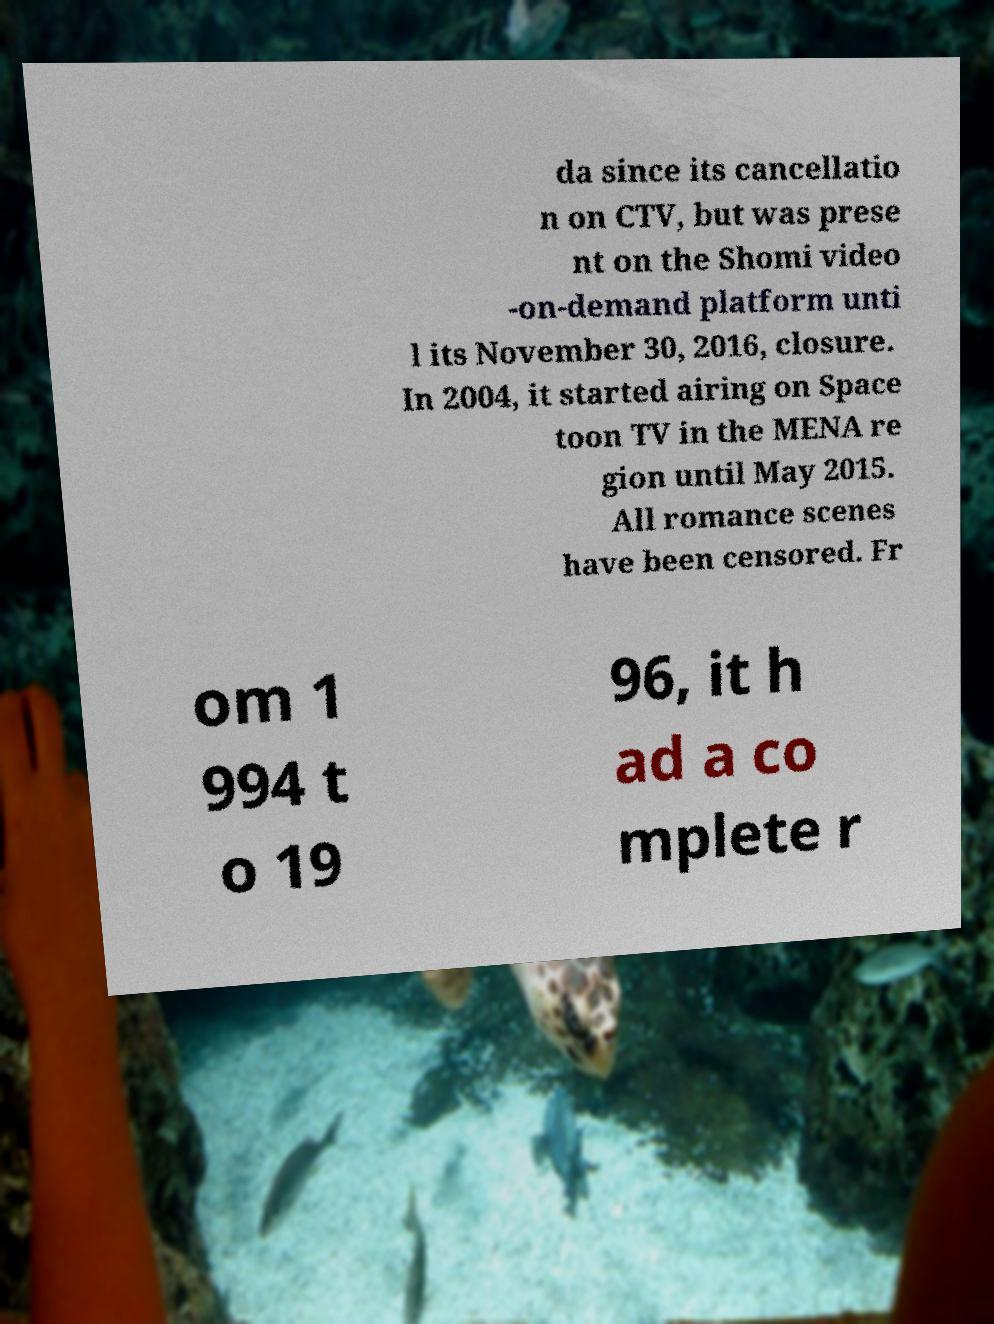There's text embedded in this image that I need extracted. Can you transcribe it verbatim? da since its cancellatio n on CTV, but was prese nt on the Shomi video -on-demand platform unti l its November 30, 2016, closure. In 2004, it started airing on Space toon TV in the MENA re gion until May 2015. All romance scenes have been censored. Fr om 1 994 t o 19 96, it h ad a co mplete r 